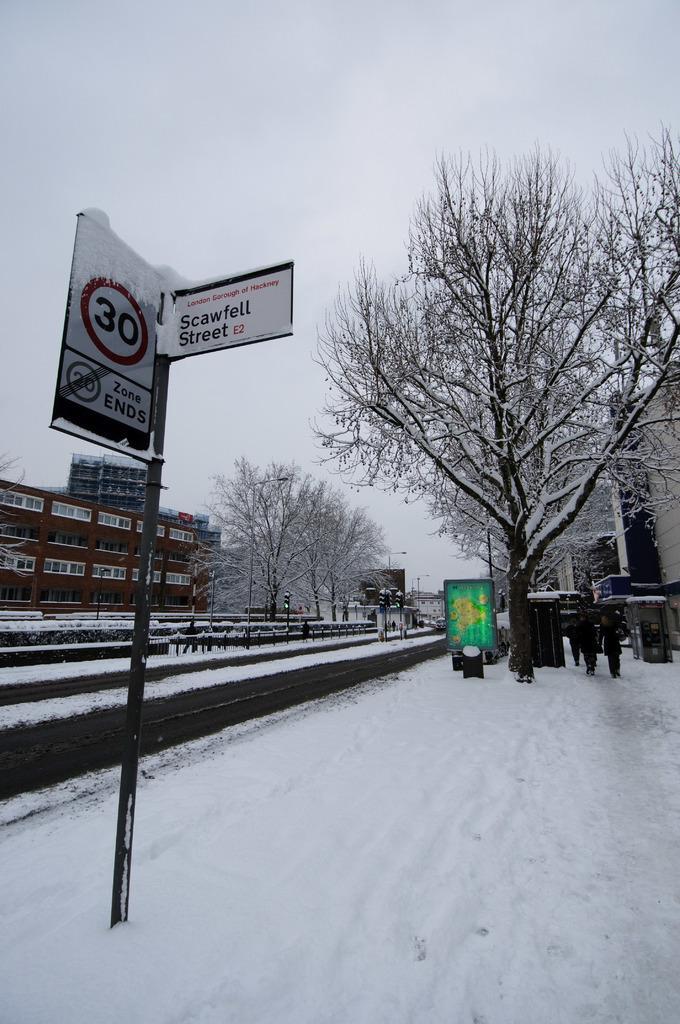In one or two sentences, can you explain what this image depicts? In this picture I can observe a pole on the left side to which two boards are fixed. There is some snow on the land. I can observe some trees and buildings in this picture. In the background there is a sky. 